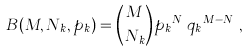<formula> <loc_0><loc_0><loc_500><loc_500>B ( M , N _ { k } , p _ { k } ) = { M \choose N _ { k } } { p _ { k } } ^ { N _ { k } } { q _ { k } } ^ { M - N _ { k } } ,</formula> 